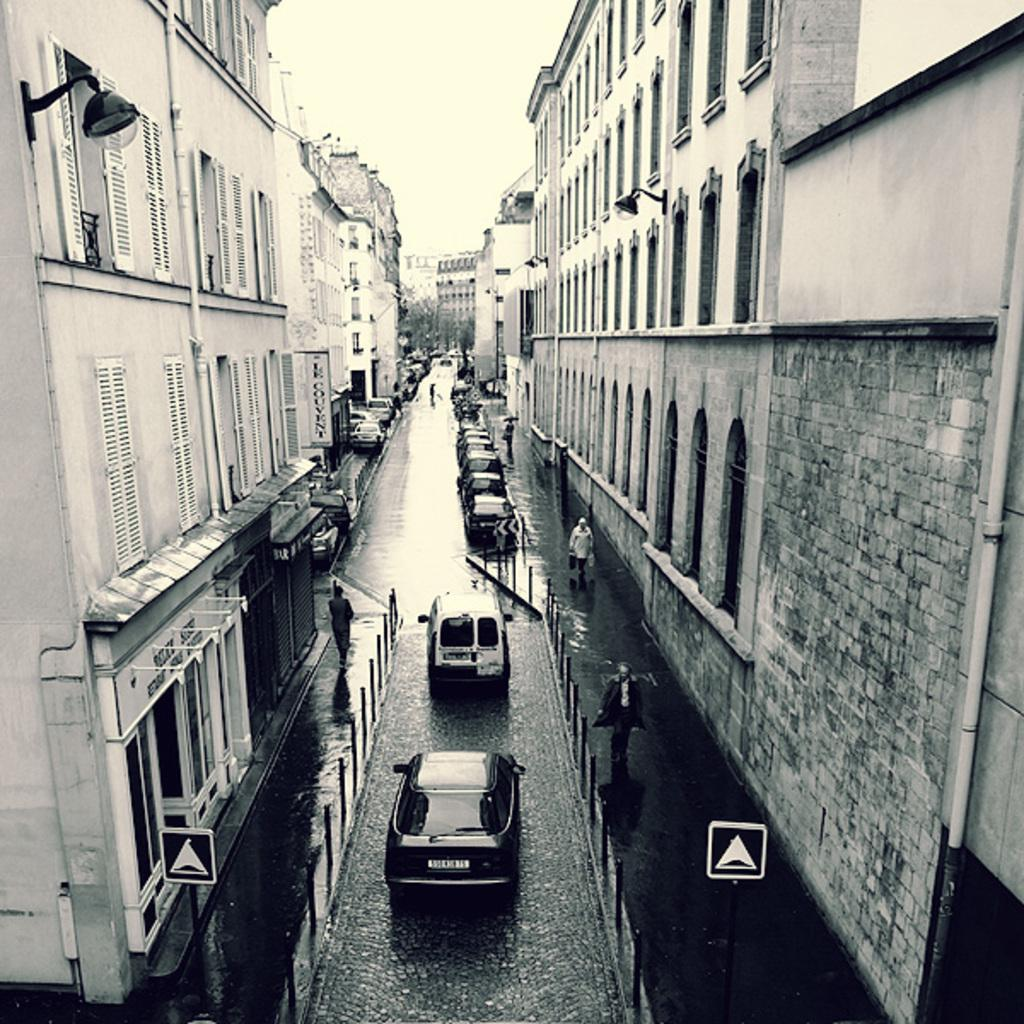What is the color scheme of the image? The image is black and white. What can be seen on the road in the image? There are vehicles on the road. What architectural features are visible in the image? There are windows, buildings, and doors visible in the image. What is the purpose of the sign board in the image? The sign board in the image provides information or directions. What are the poles used for in the image? The poles in the image might be used for supporting wires or signs. What is visible in the sky in the image? The sky is visible in the image, but no specific details about the sky can be determined from the provided facts. What type of bun is being used to hold the sign board in the image? There is no bun present in the image; the sign board is likely attached to a pole or wall. How many steps are visible in the image? There is no mention of steps in the provided facts, so it cannot be determined how many steps are visible in the image. 